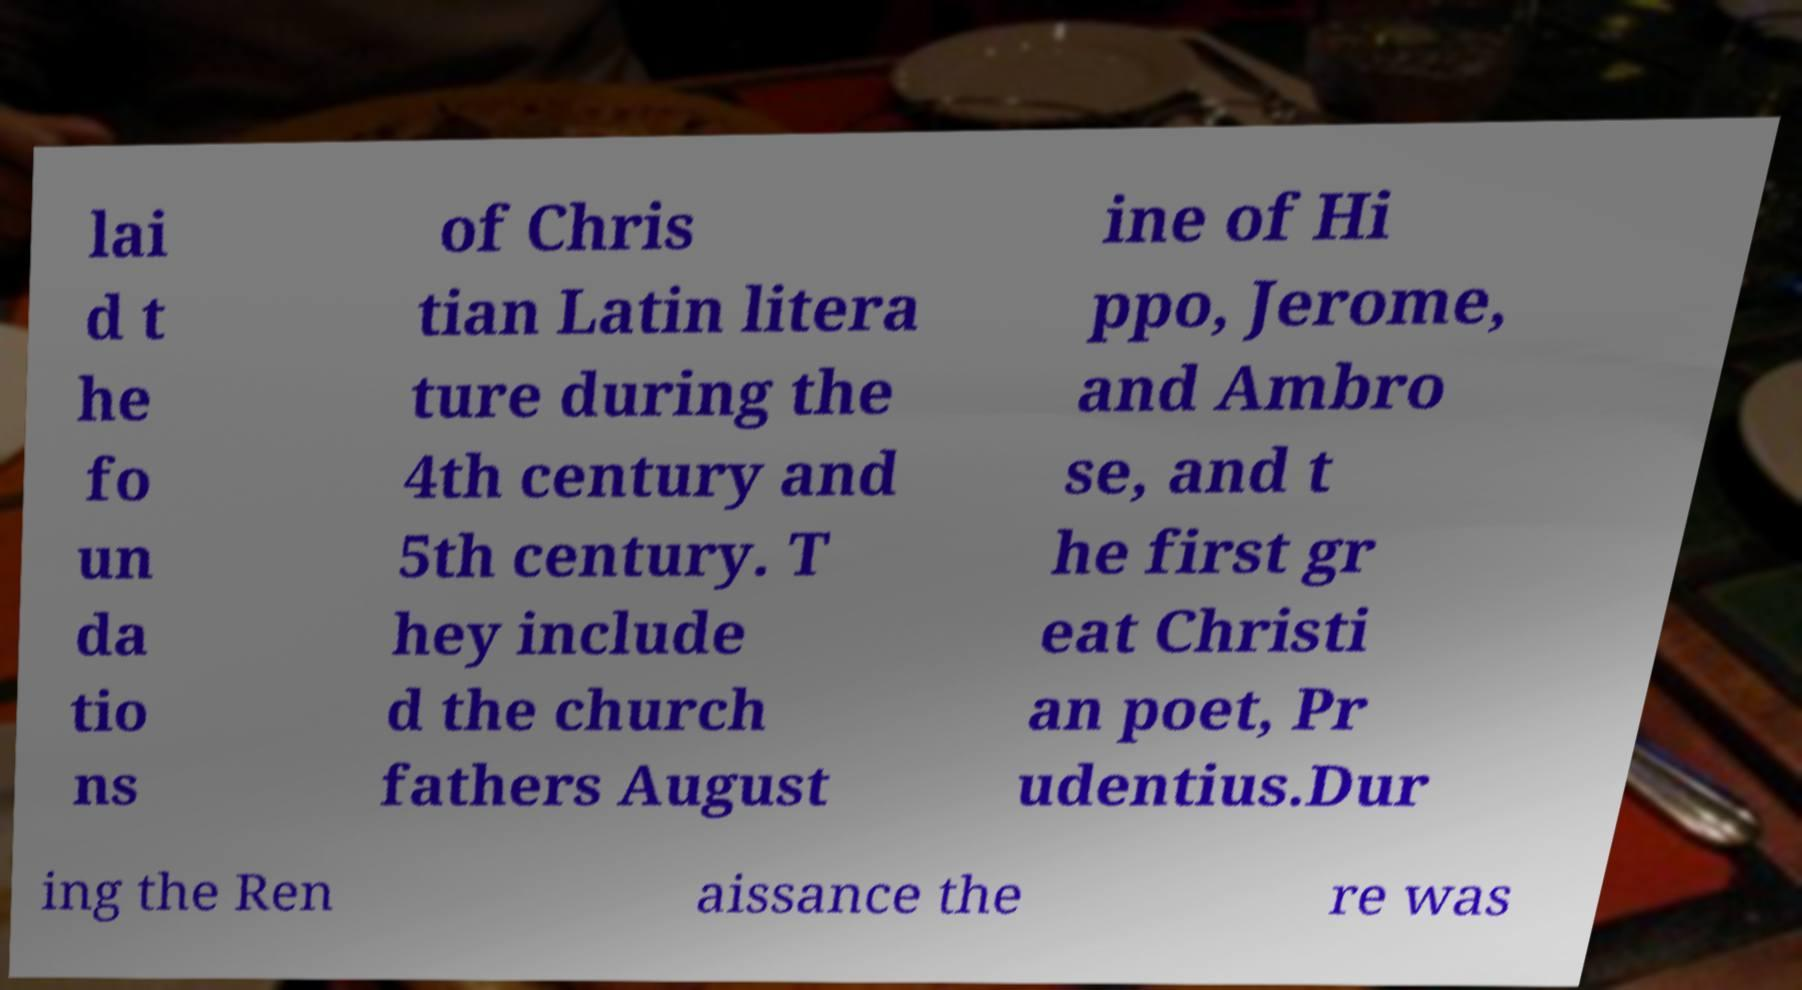Could you assist in decoding the text presented in this image and type it out clearly? lai d t he fo un da tio ns of Chris tian Latin litera ture during the 4th century and 5th century. T hey include d the church fathers August ine of Hi ppo, Jerome, and Ambro se, and t he first gr eat Christi an poet, Pr udentius.Dur ing the Ren aissance the re was 